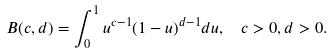<formula> <loc_0><loc_0><loc_500><loc_500>B ( c , d ) = \int _ { 0 } ^ { 1 } u ^ { c - 1 } ( 1 - u ) ^ { d - 1 } d u , \ \ c > 0 , d > 0 .</formula> 